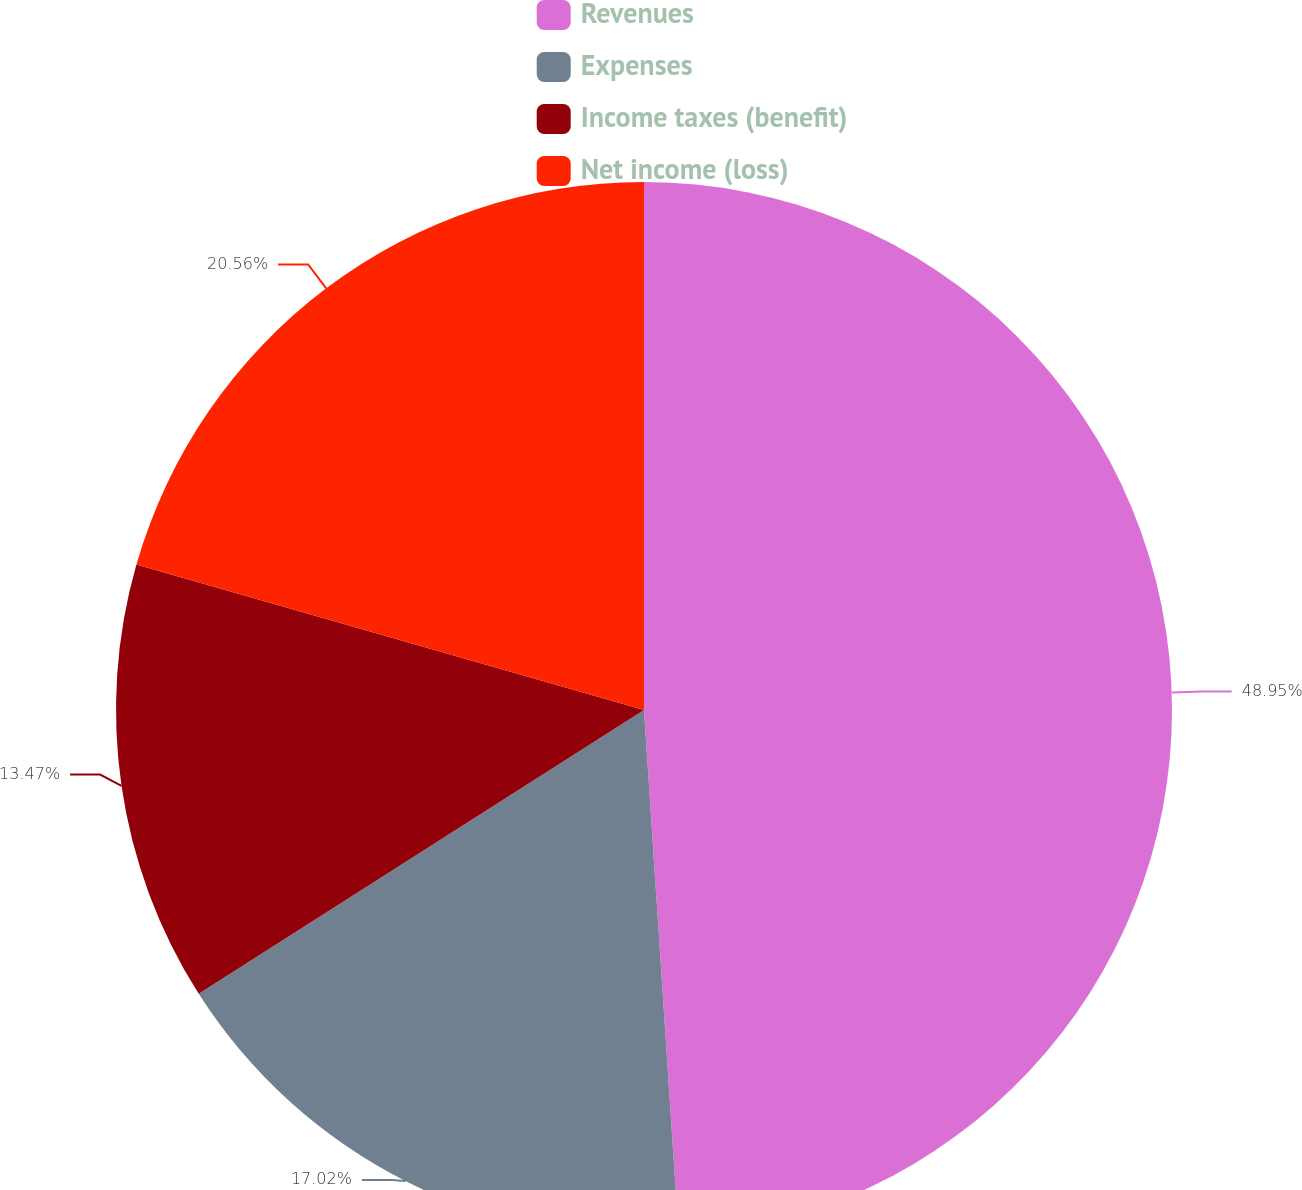<chart> <loc_0><loc_0><loc_500><loc_500><pie_chart><fcel>Revenues<fcel>Expenses<fcel>Income taxes (benefit)<fcel>Net income (loss)<nl><fcel>48.95%<fcel>17.02%<fcel>13.47%<fcel>20.56%<nl></chart> 